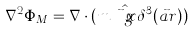Convert formula to latex. <formula><loc_0><loc_0><loc_500><loc_500>\nabla ^ { 2 } \Phi _ { M } = \nabla \cdot ( m \, \hat { \vec { g } { x } } \, \delta ^ { 3 } ( \vec { a } { r } ) )</formula> 